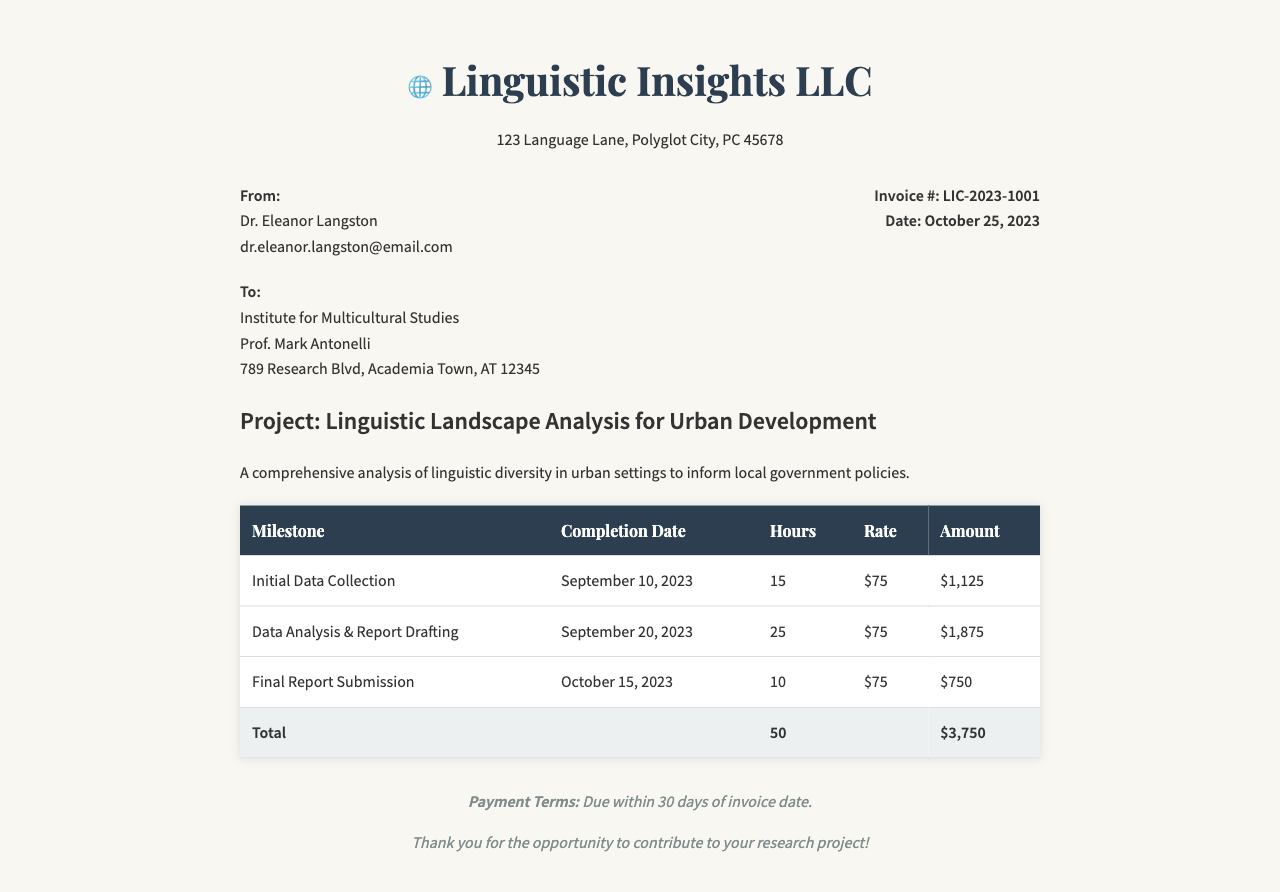What is the invoice number? The invoice number listed in the document is a unique identifier assigned to this transaction, which is LIC-2023-1001.
Answer: LIC-2023-1001 Who is the client? The client is identified in the document with a name and organization, which is the Institute for Multicultural Studies.
Answer: Institute for Multicultural Studies What is the hourly rate for the consultation services? The hourly rate specified for the services provided in the invoice is $75.
Answer: $75 How many total hours were billed? The total hours billed can be calculated by summing the hours for each milestone listed, which adds up to 50 hours.
Answer: 50 What is the total amount due? The total amount due for the services listed on the invoice is the final calculated amount shown at the end, which is $3,750.
Answer: $3,750 When was the final report submitted? The completion date for the final report submission is provided, which is October 15, 2023.
Answer: October 15, 2023 What is the payment term? The payment terms outline the conditions under which payment is expected for the services rendered, which is due within 30 days of the invoice date.
Answer: Due within 30 days What project is this invoice related to? The project name is specified at the beginning of the invoice and describes the subject of the consultation services, which is Linguistic Landscape Analysis for Urban Development.
Answer: Linguistic Landscape Analysis for Urban Development How many milestones are listed in the invoice? The number of milestones refers to the specific phases of the project as outlined in the table, totaling three separate milestones.
Answer: Three 